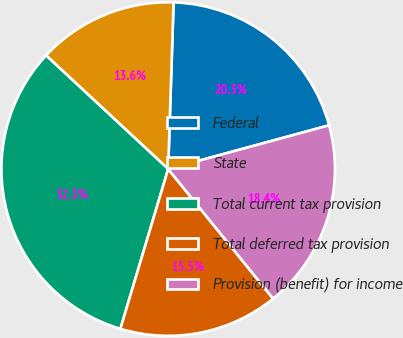<chart> <loc_0><loc_0><loc_500><loc_500><pie_chart><fcel>Federal<fcel>State<fcel>Total current tax provision<fcel>Total deferred tax provision<fcel>Provision (benefit) for income<nl><fcel>20.26%<fcel>13.59%<fcel>32.3%<fcel>15.46%<fcel>18.39%<nl></chart> 